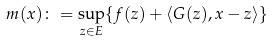Convert formula to latex. <formula><loc_0><loc_0><loc_500><loc_500>m ( x ) \colon = \sup _ { z \in E } \{ f ( z ) + \langle G ( z ) , x - z \rangle \}</formula> 